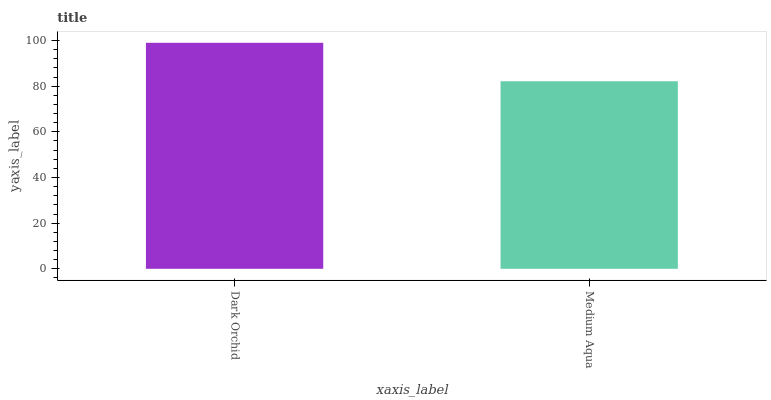Is Medium Aqua the minimum?
Answer yes or no. Yes. Is Dark Orchid the maximum?
Answer yes or no. Yes. Is Medium Aqua the maximum?
Answer yes or no. No. Is Dark Orchid greater than Medium Aqua?
Answer yes or no. Yes. Is Medium Aqua less than Dark Orchid?
Answer yes or no. Yes. Is Medium Aqua greater than Dark Orchid?
Answer yes or no. No. Is Dark Orchid less than Medium Aqua?
Answer yes or no. No. Is Dark Orchid the high median?
Answer yes or no. Yes. Is Medium Aqua the low median?
Answer yes or no. Yes. Is Medium Aqua the high median?
Answer yes or no. No. Is Dark Orchid the low median?
Answer yes or no. No. 